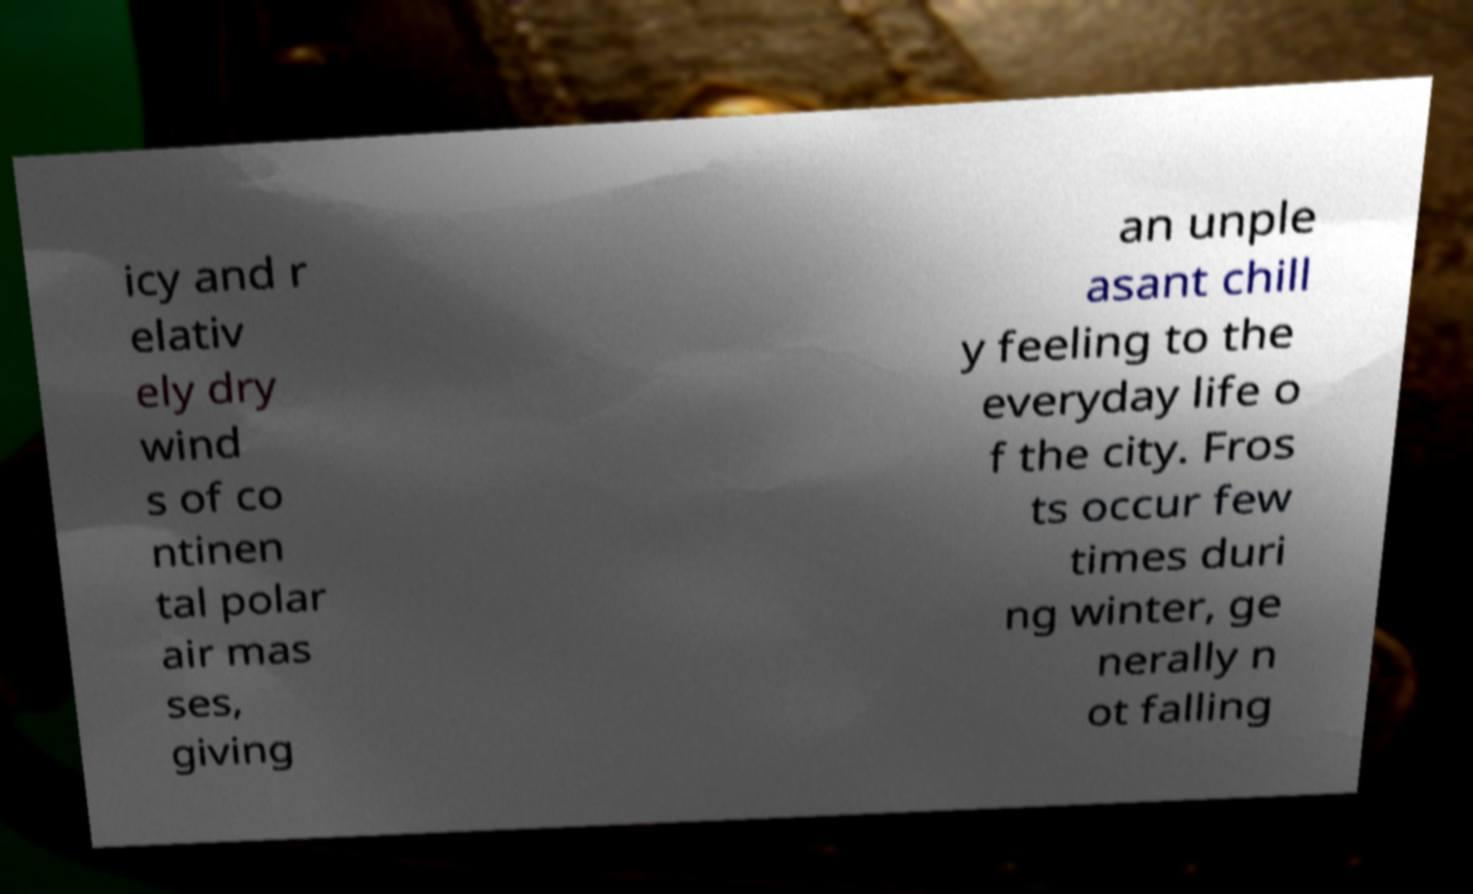Please read and relay the text visible in this image. What does it say? icy and r elativ ely dry wind s of co ntinen tal polar air mas ses, giving an unple asant chill y feeling to the everyday life o f the city. Fros ts occur few times duri ng winter, ge nerally n ot falling 